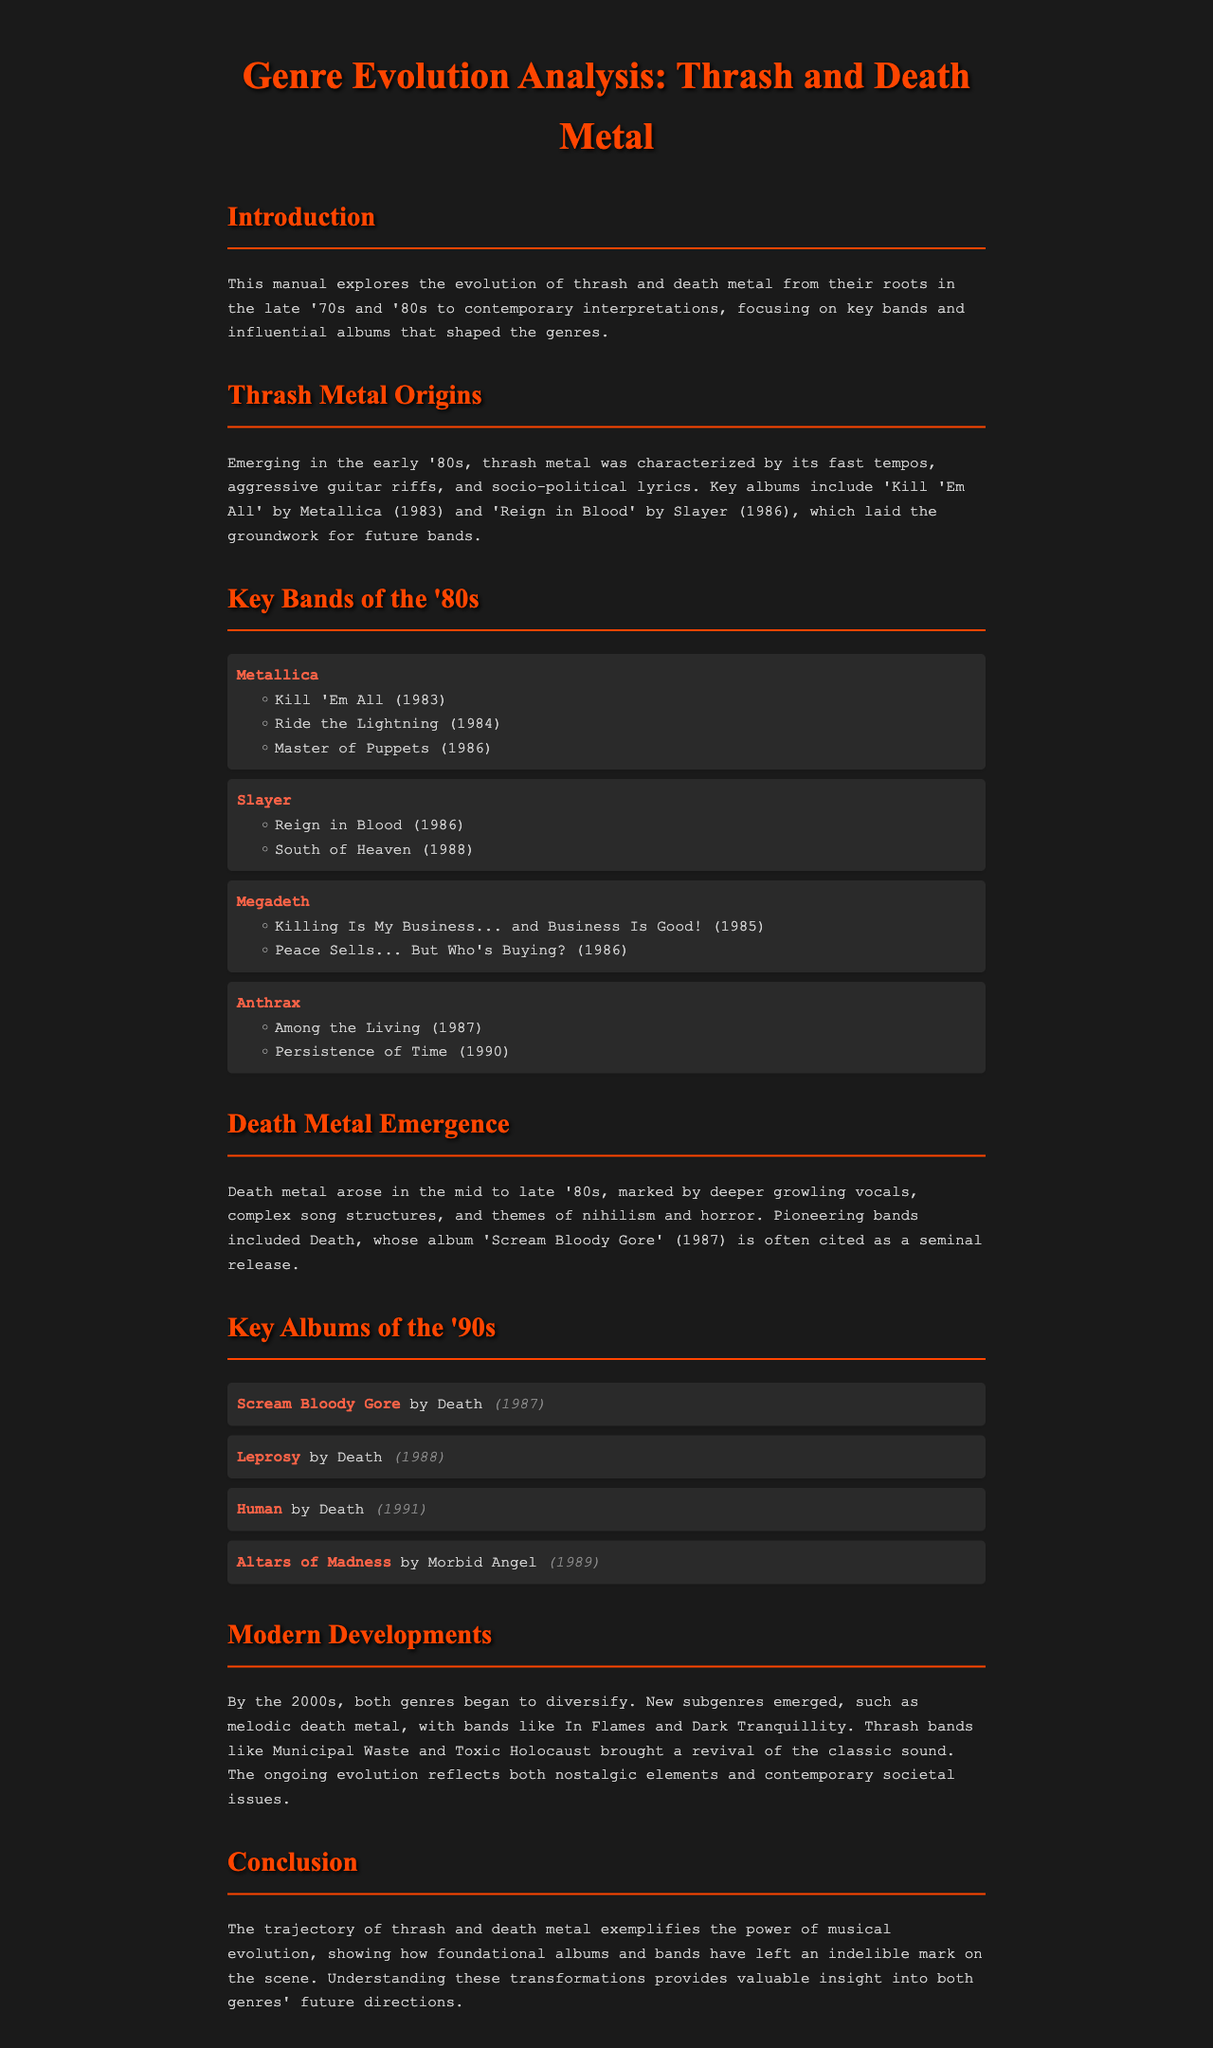What is the title of the document? The title of the document is specified in the HTML code.
Answer: Genre Evolution Analysis: Thrash and Death Metal Which band released 'Reign in Blood'? The document lists bands and their notable albums.
Answer: Slayer In which year was 'Scream Bloody Gore' released? The manual lists key albums along with their release years.
Answer: 1987 Name one band that contributed to the revival of thrash metal. The document mentions contemporary bands associated with this revival.
Answer: Municipal Waste What genre emerged in the mid to late '80s? The document identifies the emergence of death metal during that period.
Answer: Death metal How many albums by Metallica are listed in the '80s section? The document details the notable albums by key bands in the '80s.
Answer: Three What musical elements characterize thrash metal? The introductory section outlines defining characteristics of thrash metal.
Answer: Fast tempos, aggressive guitar riffs Which album is considered a seminal release for death metal? The document specifically cites 'Scream Bloody Gore' as a pivotal album for the genre.
Answer: Scream Bloody Gore What overarching theme is noted in the evolution of both genres? The conclusion reflects on the nature of musical evolution and themes within the document.
Answer: Musical evolution 